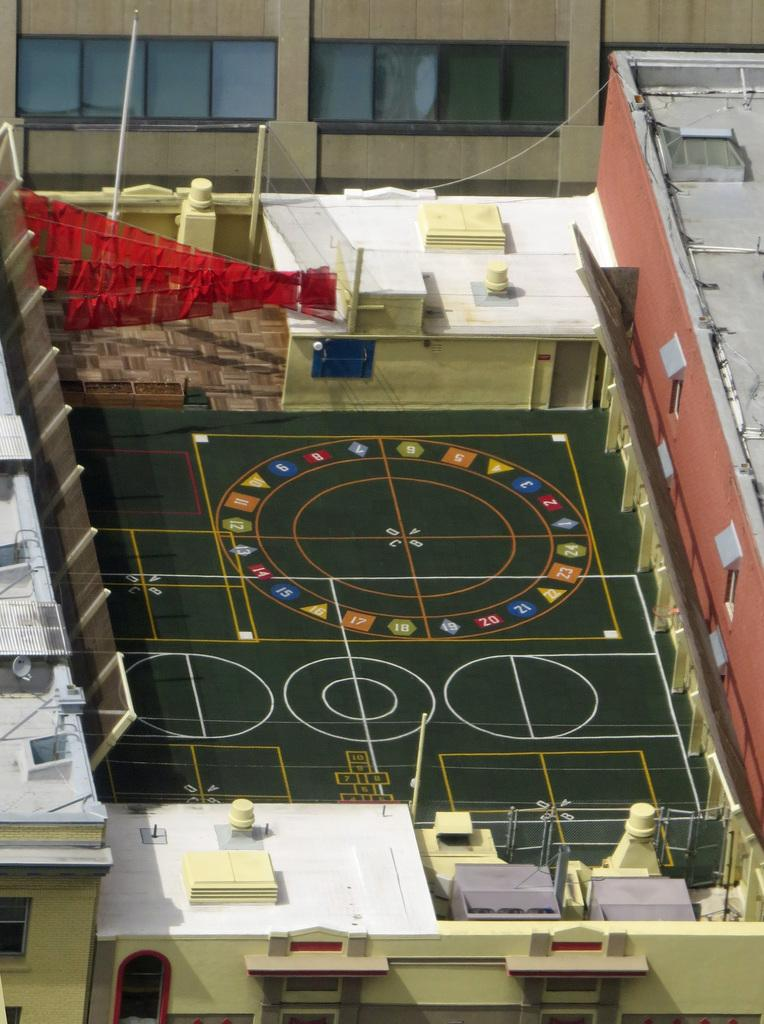What type of structures can be seen in the image? There are buildings in the image. What prose can be read on the walls of the buildings in the image? There is no prose visible on the walls of the buildings in the image. 